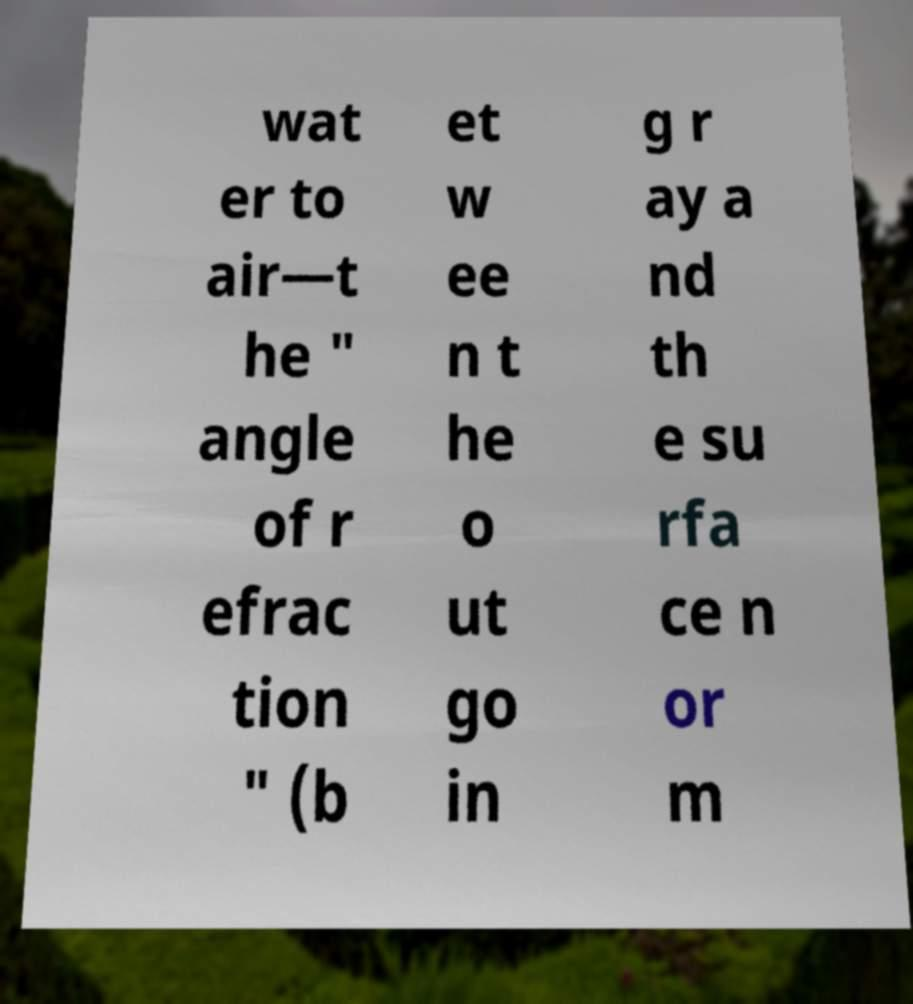Can you accurately transcribe the text from the provided image for me? wat er to air—t he " angle of r efrac tion " (b et w ee n t he o ut go in g r ay a nd th e su rfa ce n or m 